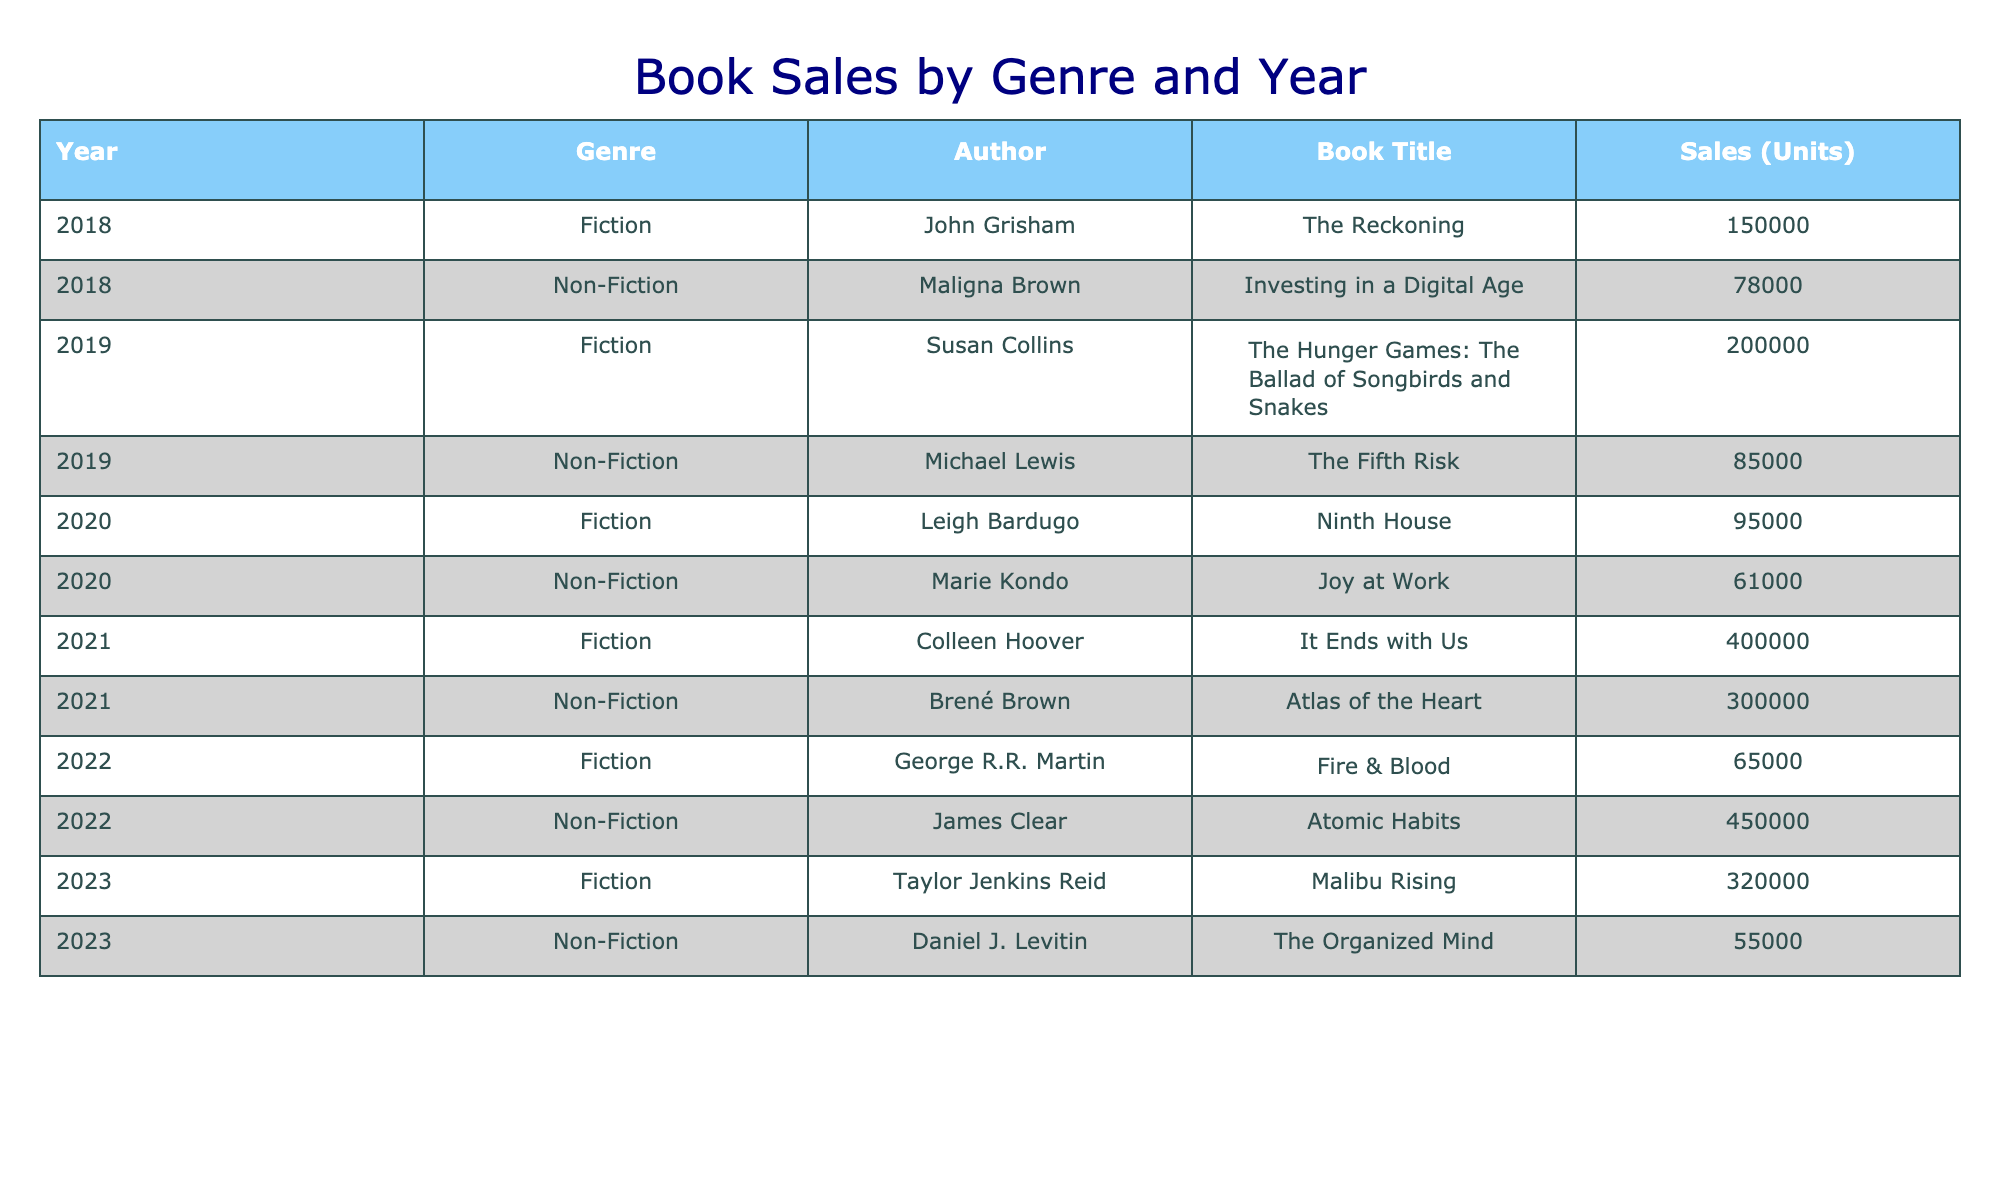What was the total sales in Fiction for 2021? For 2021, the table shows one entry under Fiction: Colleen Hoover's "It Ends with Us" with sales of 400,000 units. Since there are no other Fiction entries for that year, the total is just this single value: 400,000.
Answer: 400000 Which genre had higher sales in 2022: Fiction or Non-Fiction? In 2022, Fiction sales were 65,000 (George R.R. Martin's "Fire & Blood") compared to Non-Fiction sales of 450,000 (James Clear's "Atomic Habits"). Non-Fiction sales are greater than Fiction sales by 385,000.
Answer: Non-Fiction Was there ever a year when Non-Fiction sales exceeded 300,000 units? The table shows Non-Fiction sales at 300,000 units in 2021 (Brené Brown's "Atlas of the Heart") and 450,000 units in 2022 (James Clear's "Atomic Habits"). Therefore, there were years when Non-Fiction sales exceeded 300,000.
Answer: Yes What is the average sales across all genres for the year 2020? The total sales for 2020 are the sum of Fiction (95,000) and Non-Fiction (61,000), which totals 156,000 units. There are two genres, so the average is 156,000 divided by 2, which equals 78,000.
Answer: 78000 Which author's book had the highest sales in the table? To find the highest sales, we look across all entries in the table. Colleen Hoover's "It Ends with Us" in 2021 had sales of 400,000 units, which is the highest compared to others listed.
Answer: Colleen Hoover How many total units were sold for Non-Fiction books over all years? The total sales for Non-Fiction can be calculated by adding the values: 78,000 (2018) + 85,000 (2019) + 61,000 (2020) + 300,000 (2021) + 450,000 (2022) + 55,000 (2023) = 1,009,000 total units sold for Non-Fiction.
Answer: 1009000 In which year did Fiction sales peak, and what were the sales figures? Looking at the years, 2021 shows Fiction sales of 400,000 (Colleen Hoover) which is greater than other years. Thus, 2021 is the peak year for Fiction sales at 400,000 units.
Answer: 2021, 400000 Did the sales of Fiction increase from 2019 to 2020? In 2019, Fiction sales were 200,000 (Susan Collins) and in 2020, they dropped to 95,000 (Leigh Bardugo). Since 95,000 is less than 200,000, they did not increase.
Answer: No What is the difference in sales between the best-selling Fiction and Non-Fiction books in 2021? The best-selling Fiction book in 2021 is "It Ends with Us" with 400,000 units, and the best-selling Non-Fiction is "Atlas of the Heart" with 300,000 units. The difference is 400,000 - 300,000 = 100,000.
Answer: 100000 